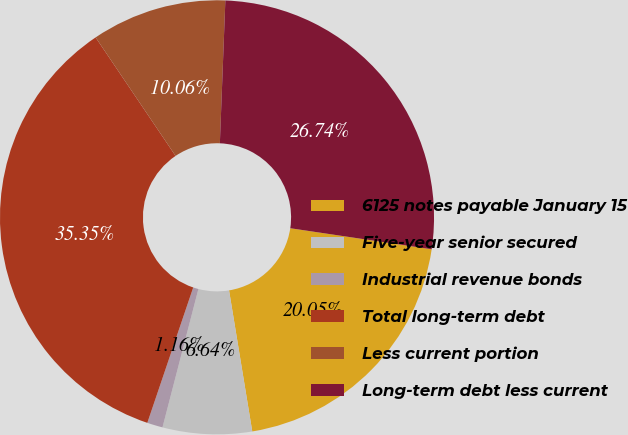Convert chart. <chart><loc_0><loc_0><loc_500><loc_500><pie_chart><fcel>6125 notes payable January 15<fcel>Five-year senior secured<fcel>Industrial revenue bonds<fcel>Total long-term debt<fcel>Less current portion<fcel>Long-term debt less current<nl><fcel>20.05%<fcel>6.64%<fcel>1.16%<fcel>35.35%<fcel>10.06%<fcel>26.74%<nl></chart> 